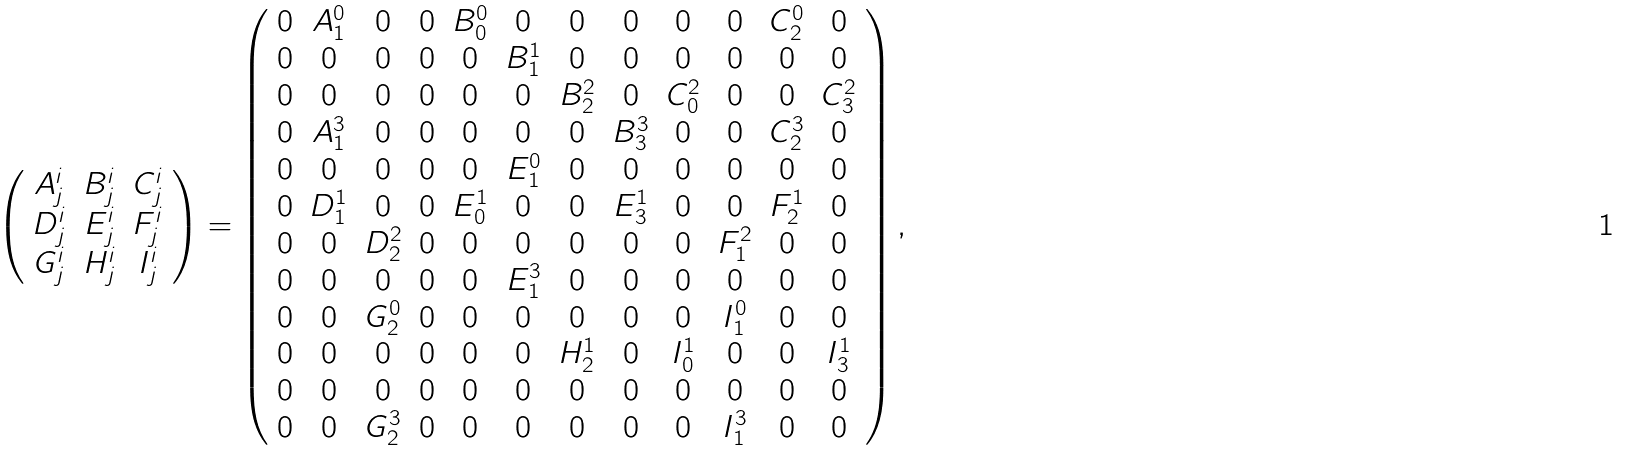<formula> <loc_0><loc_0><loc_500><loc_500>\left ( \begin{array} { c c c } A _ { j } ^ { i } & B _ { j } ^ { i } & C _ { j } ^ { i } \\ D _ { j } ^ { i } & E _ { j } ^ { i } & F _ { j } ^ { i } \\ G _ { j } ^ { i } & H _ { j } ^ { i } & I _ { j } ^ { i } \end{array} \right ) = \left ( \begin{array} { c c c c c c c c c c c c } 0 & A _ { 1 } ^ { 0 } & 0 & 0 & B _ { 0 } ^ { 0 } & 0 & 0 & 0 & 0 & 0 & C _ { 2 } ^ { 0 } & 0 \\ 0 & 0 & 0 & 0 & 0 & B _ { 1 } ^ { 1 } & 0 & 0 & 0 & 0 & 0 & 0 \\ 0 & 0 & 0 & 0 & 0 & 0 & B _ { 2 } ^ { 2 } & 0 & C _ { 0 } ^ { 2 } & 0 & 0 & C _ { 3 } ^ { 2 } \\ 0 & A _ { 1 } ^ { 3 } & 0 & 0 & 0 & 0 & 0 & B _ { 3 } ^ { 3 } & 0 & 0 & C _ { 2 } ^ { 3 } & 0 \\ 0 & 0 & 0 & 0 & 0 & E _ { 1 } ^ { 0 } & 0 & 0 & 0 & 0 & 0 & 0 \\ 0 & D _ { 1 } ^ { 1 } & 0 & 0 & E _ { 0 } ^ { 1 } & 0 & 0 & E _ { 3 } ^ { 1 } & 0 & 0 & F _ { 2 } ^ { 1 } & 0 \\ 0 & 0 & D _ { 2 } ^ { 2 } & 0 & 0 & 0 & 0 & 0 & 0 & F _ { 1 } ^ { 2 } & 0 & 0 \\ 0 & 0 & 0 & 0 & 0 & E _ { 1 } ^ { 3 } & 0 & 0 & 0 & 0 & 0 & 0 \\ 0 & 0 & G _ { 2 } ^ { 0 } & 0 & 0 & 0 & 0 & 0 & 0 & I _ { 1 } ^ { 0 } & 0 & 0 \\ 0 & 0 & 0 & 0 & 0 & 0 & H _ { 2 } ^ { 1 } & 0 & I _ { 0 } ^ { 1 } & 0 & 0 & I _ { 3 } ^ { 1 } \\ 0 & 0 & 0 & 0 & 0 & 0 & 0 & 0 & 0 & 0 & 0 & 0 \\ 0 & 0 & G _ { 2 } ^ { 3 } & 0 & 0 & 0 & 0 & 0 & 0 & I _ { 1 } ^ { 3 } & 0 & 0 \end{array} \right ) ,</formula> 